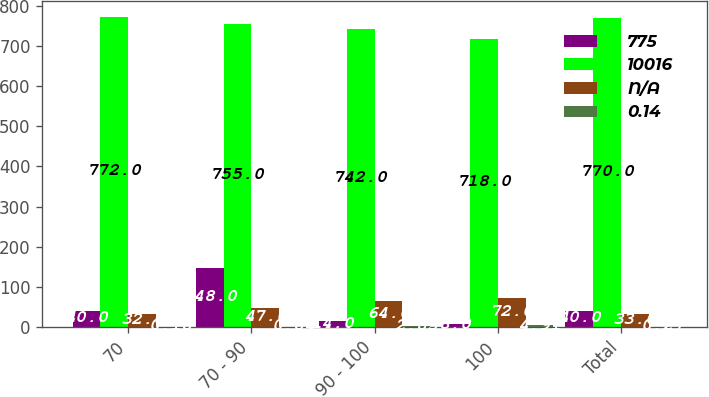Convert chart. <chart><loc_0><loc_0><loc_500><loc_500><stacked_bar_chart><ecel><fcel>70<fcel>70 - 90<fcel>90 - 100<fcel>100<fcel>Total<nl><fcel>775<fcel>40<fcel>148<fcel>14<fcel>8<fcel>40<nl><fcel>10016<fcel>772<fcel>755<fcel>742<fcel>718<fcel>770<nl><fcel>nan<fcel>32<fcel>47<fcel>64<fcel>72<fcel>33<nl><fcel>0.14<fcel>0.18<fcel>0.84<fcel>2.85<fcel>4.91<fcel>0.27<nl></chart> 